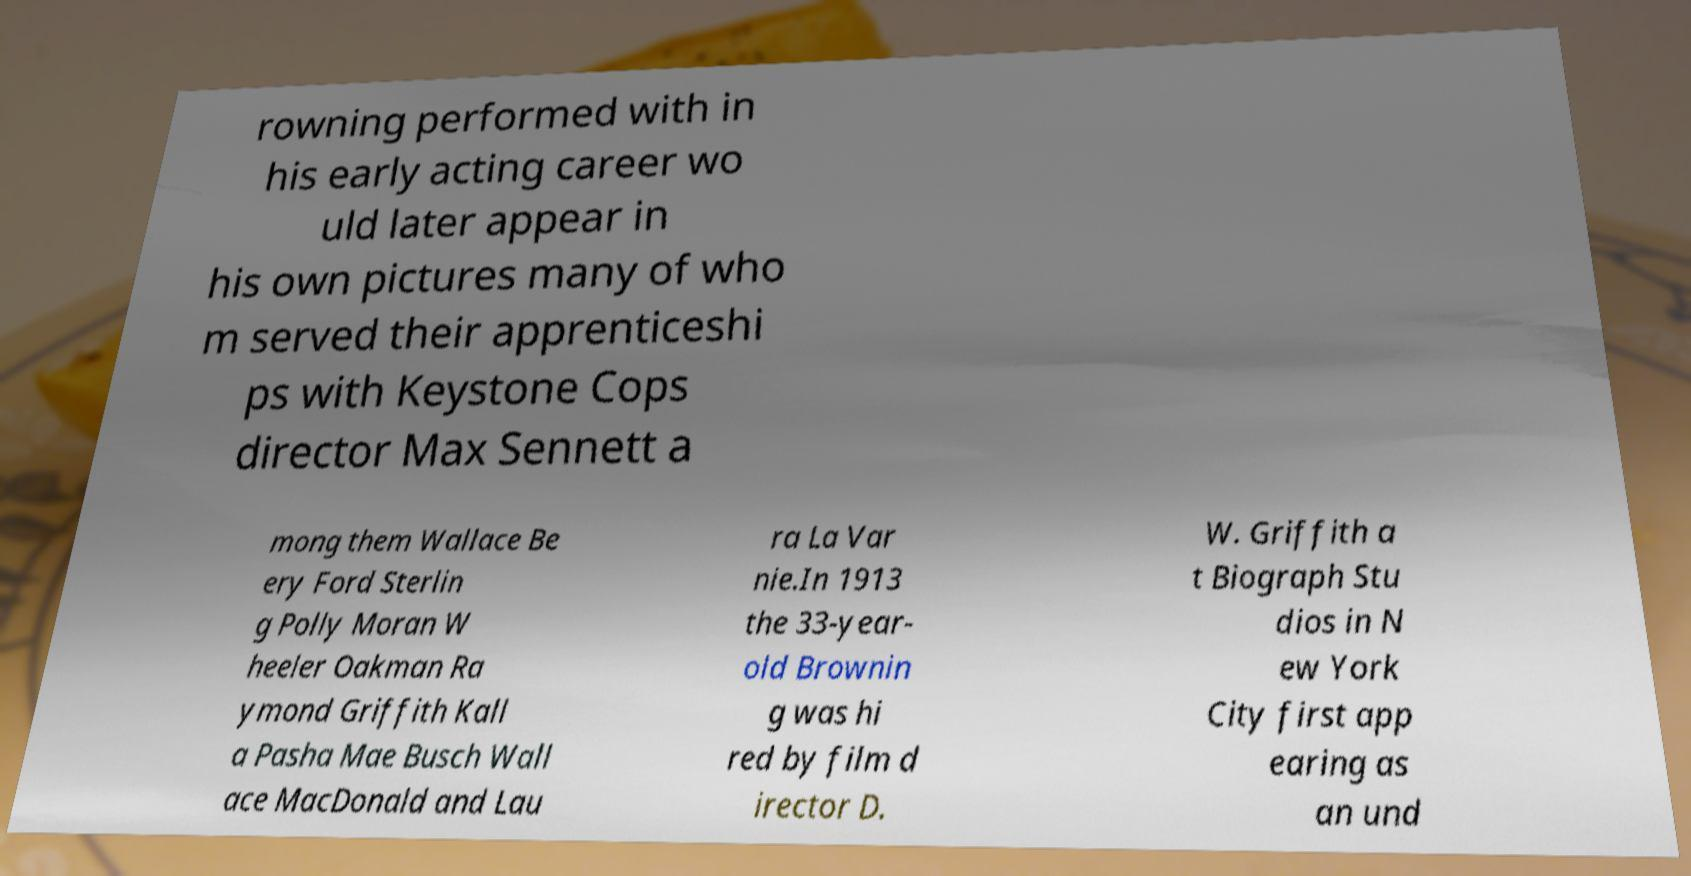Please identify and transcribe the text found in this image. rowning performed with in his early acting career wo uld later appear in his own pictures many of who m served their apprenticeshi ps with Keystone Cops director Max Sennett a mong them Wallace Be ery Ford Sterlin g Polly Moran W heeler Oakman Ra ymond Griffith Kall a Pasha Mae Busch Wall ace MacDonald and Lau ra La Var nie.In 1913 the 33-year- old Brownin g was hi red by film d irector D. W. Griffith a t Biograph Stu dios in N ew York City first app earing as an und 